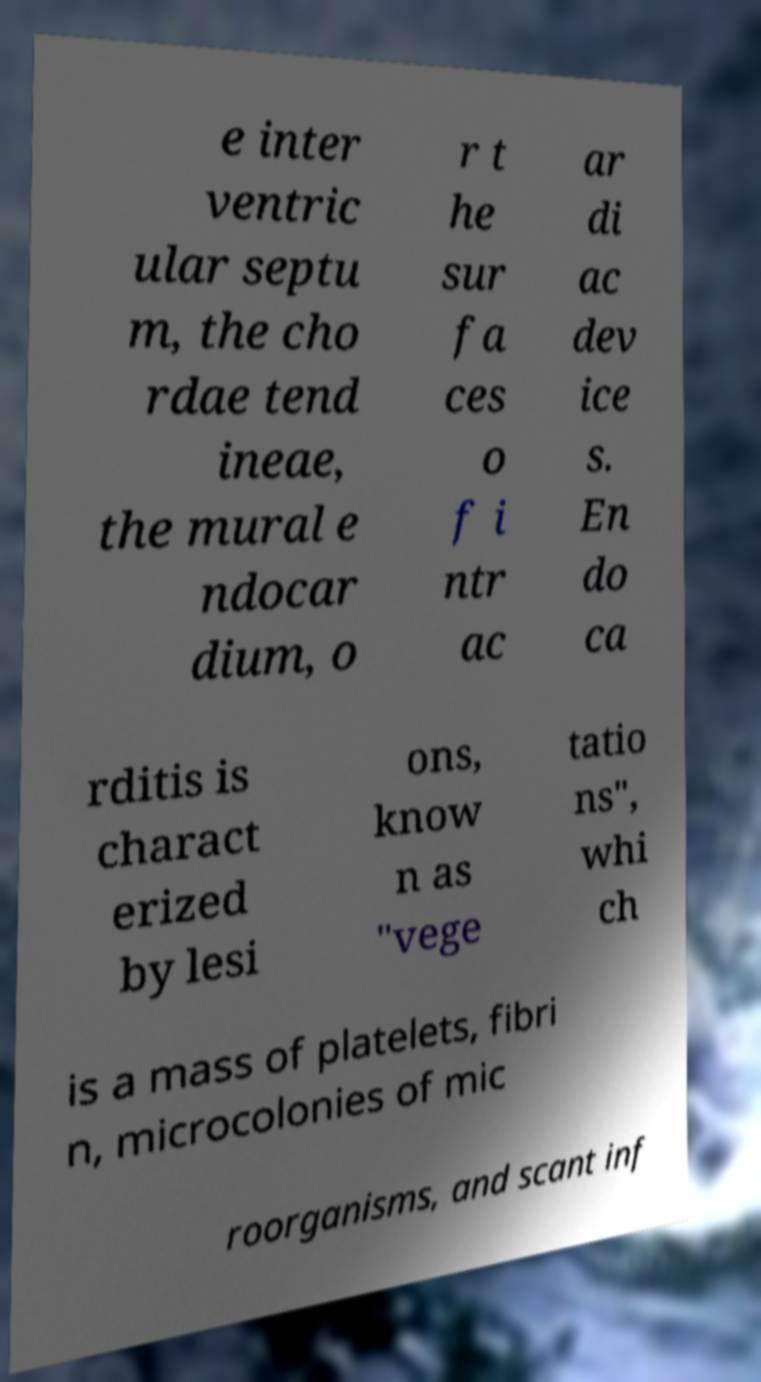Can you accurately transcribe the text from the provided image for me? e inter ventric ular septu m, the cho rdae tend ineae, the mural e ndocar dium, o r t he sur fa ces o f i ntr ac ar di ac dev ice s. En do ca rditis is charact erized by lesi ons, know n as "vege tatio ns", whi ch is a mass of platelets, fibri n, microcolonies of mic roorganisms, and scant inf 